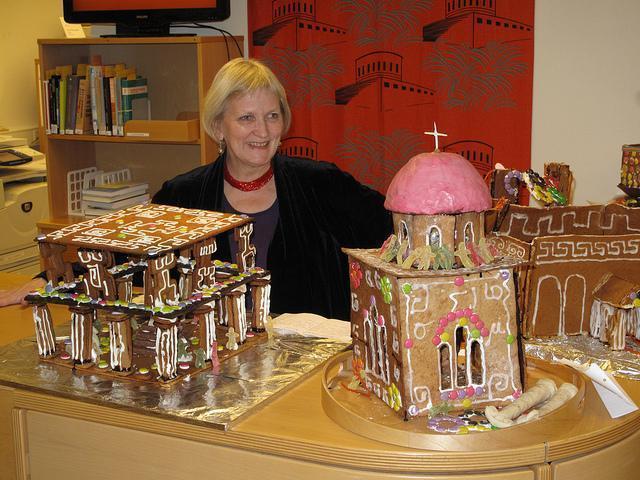What are these buildings mostly made of?
Select the accurate answer and provide justification: `Answer: choice
Rationale: srationale.`
Options: Plastic, gingerbread, fiberglass, gingersnap. Answer: gingerbread.
Rationale: The buildings are made of gingerbread. 